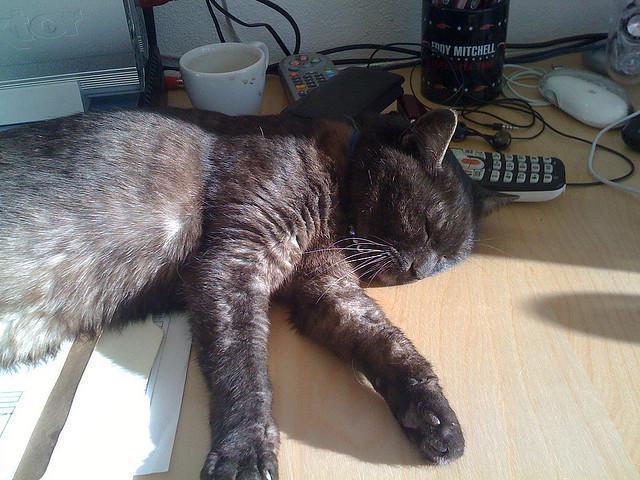How many remotes are on the desk?
Give a very brief answer. 2. How many cups can be seen?
Give a very brief answer. 2. How many remotes are in the picture?
Give a very brief answer. 2. How many people are wearing a red wig?
Give a very brief answer. 0. 